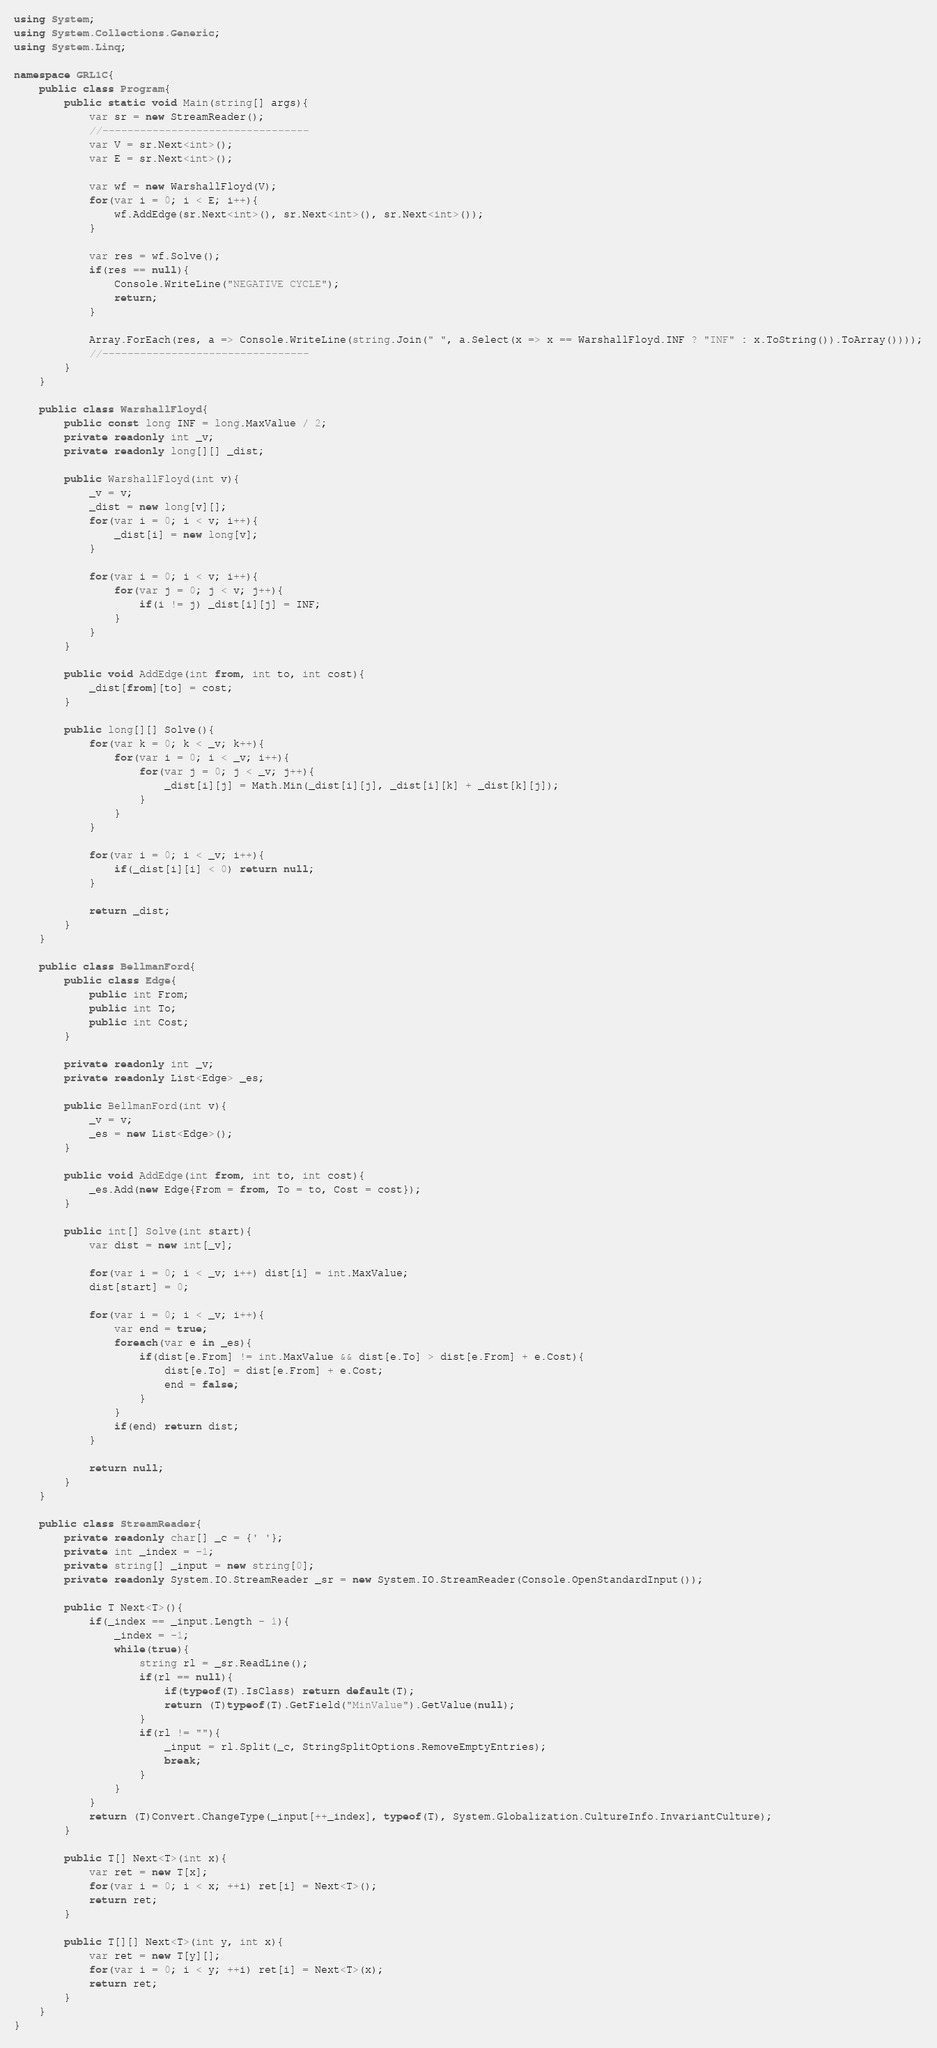Convert code to text. <code><loc_0><loc_0><loc_500><loc_500><_C#_>using System;
using System.Collections.Generic;
using System.Linq;

namespace GRL1C{
    public class Program{
        public static void Main(string[] args){
            var sr = new StreamReader();
            //---------------------------------
            var V = sr.Next<int>();
            var E = sr.Next<int>();

            var wf = new WarshallFloyd(V);
            for(var i = 0; i < E; i++){
                wf.AddEdge(sr.Next<int>(), sr.Next<int>(), sr.Next<int>());
            }

            var res = wf.Solve();
            if(res == null){
                Console.WriteLine("NEGATIVE CYCLE");
                return;
            }

            Array.ForEach(res, a => Console.WriteLine(string.Join(" ", a.Select(x => x == WarshallFloyd.INF ? "INF" : x.ToString()).ToArray())));
            //---------------------------------
        }
    }

    public class WarshallFloyd{
        public const long INF = long.MaxValue / 2;
        private readonly int _v;
        private readonly long[][] _dist;

        public WarshallFloyd(int v){
            _v = v;
            _dist = new long[v][];
            for(var i = 0; i < v; i++){
                _dist[i] = new long[v];
            }

            for(var i = 0; i < v; i++){
                for(var j = 0; j < v; j++){
                    if(i != j) _dist[i][j] = INF;
                }
            }
        }

        public void AddEdge(int from, int to, int cost){
            _dist[from][to] = cost;
        }

        public long[][] Solve(){
            for(var k = 0; k < _v; k++){
                for(var i = 0; i < _v; i++){
                    for(var j = 0; j < _v; j++){
                        _dist[i][j] = Math.Min(_dist[i][j], _dist[i][k] + _dist[k][j]);
                    }
                }
            }

            for(var i = 0; i < _v; i++){
                if(_dist[i][i] < 0) return null;
            }

            return _dist;
        }
    }

    public class BellmanFord{
        public class Edge{
            public int From;
            public int To;
            public int Cost;
        }

        private readonly int _v;
        private readonly List<Edge> _es;

        public BellmanFord(int v){
            _v = v;
            _es = new List<Edge>();
        }

        public void AddEdge(int from, int to, int cost){
            _es.Add(new Edge{From = from, To = to, Cost = cost});
        }

        public int[] Solve(int start){
            var dist = new int[_v];

            for(var i = 0; i < _v; i++) dist[i] = int.MaxValue;
            dist[start] = 0;

            for(var i = 0; i < _v; i++){
                var end = true;
                foreach(var e in _es){
                    if(dist[e.From] != int.MaxValue && dist[e.To] > dist[e.From] + e.Cost){
                        dist[e.To] = dist[e.From] + e.Cost;
                        end = false;
                    }
                }
                if(end) return dist;
            }

            return null;
        }
    }

    public class StreamReader{
        private readonly char[] _c = {' '};
        private int _index = -1;
        private string[] _input = new string[0];
        private readonly System.IO.StreamReader _sr = new System.IO.StreamReader(Console.OpenStandardInput());

        public T Next<T>(){
            if(_index == _input.Length - 1){
                _index = -1;
                while(true){
                    string rl = _sr.ReadLine();
                    if(rl == null){
                        if(typeof(T).IsClass) return default(T);
                        return (T)typeof(T).GetField("MinValue").GetValue(null);
                    }
                    if(rl != ""){
                        _input = rl.Split(_c, StringSplitOptions.RemoveEmptyEntries);
                        break;
                    }
                }
            }
            return (T)Convert.ChangeType(_input[++_index], typeof(T), System.Globalization.CultureInfo.InvariantCulture);
        }

        public T[] Next<T>(int x){
            var ret = new T[x];
            for(var i = 0; i < x; ++i) ret[i] = Next<T>();
            return ret;
        }

        public T[][] Next<T>(int y, int x){
            var ret = new T[y][];
            for(var i = 0; i < y; ++i) ret[i] = Next<T>(x);
            return ret;
        }
    }
}</code> 